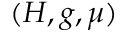<formula> <loc_0><loc_0><loc_500><loc_500>( H , g , \mu )</formula> 